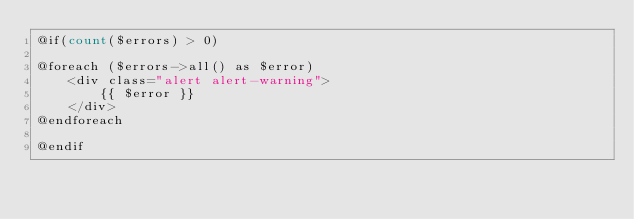Convert code to text. <code><loc_0><loc_0><loc_500><loc_500><_PHP_>@if(count($errors) > 0)

@foreach ($errors->all() as $error)
    <div class="alert alert-warning">
        {{ $error }}
    </div>
@endforeach

@endif</code> 